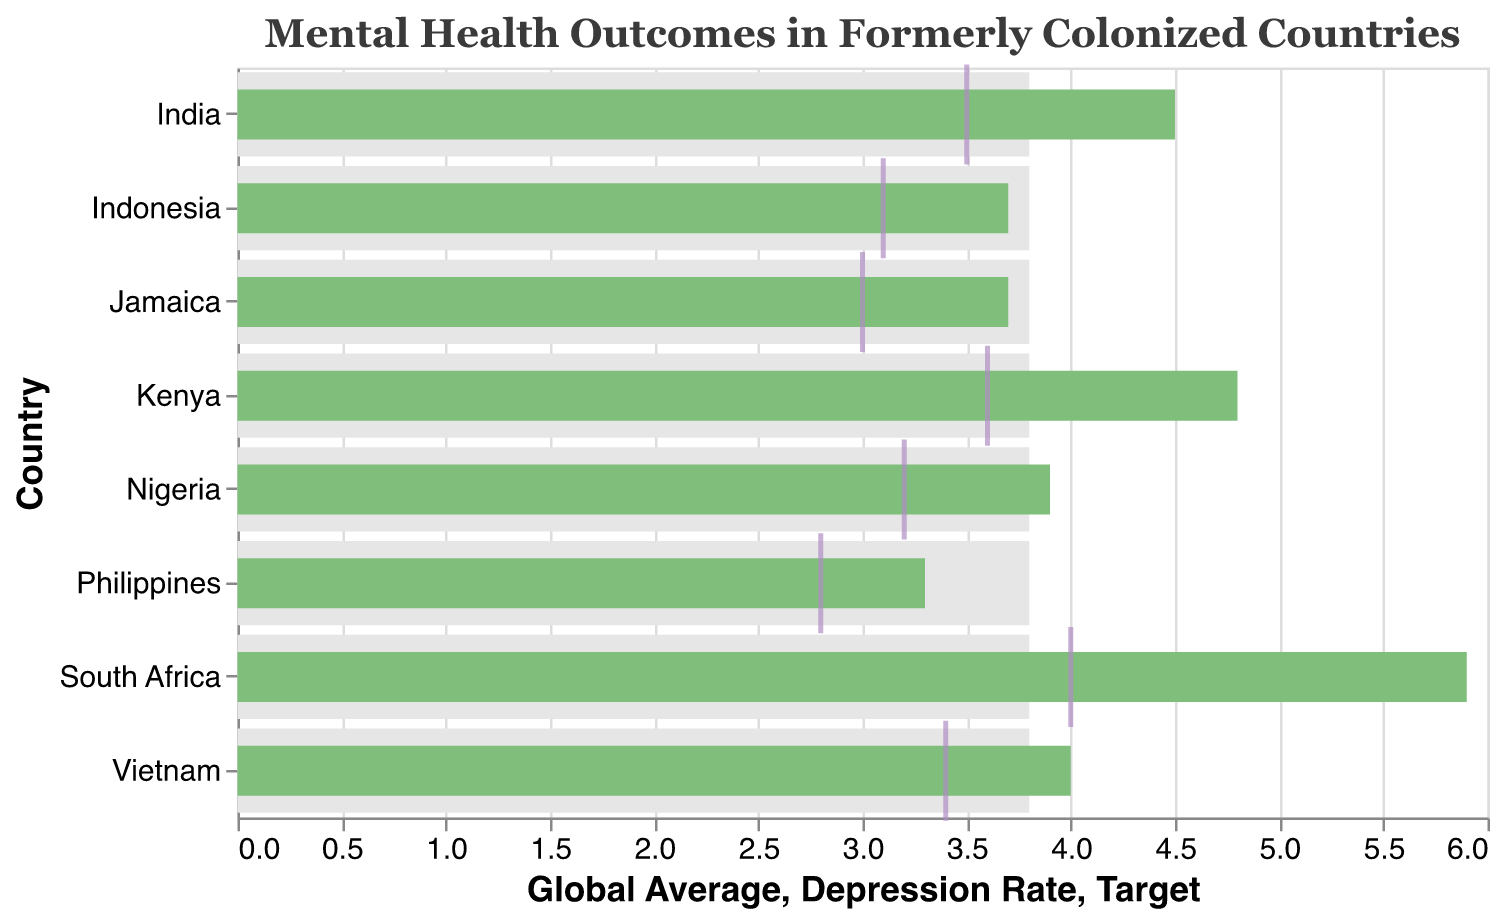What's the title of the chart? The title of the chart is given at the top and clearly states "Mental Health Outcomes in Formerly Colonized Countries".
Answer: Mental Health Outcomes in Formerly Colonized Countries What is the highest depression rate among the countries listed? By looking at the length of the green bars that represent depression rates, the entry for South Africa is the longest, indicating it has the highest rate at 5.9.
Answer: 5.9 Which country's depression rate is closest to the global average? Comparing the lengths of the green bars (depression rates) to the gray bars (global average), Nigeria and Jamaica have depression rates quite close to the global average of 3.8. Among them, Jamaica has the closest rate at 3.7.
Answer: Jamaica How does the depression rate in Kenya compare to its target? The green bar for Kenya representing its depression rate (4.8) can be compared to its tick mark for the target (3.6), showing that Kenya's rate is higher than its target.
Answer: Higher What is the difference between South Africa's depression rate and the global average? South Africa's depression rate is 5.9 and the global average is 3.8. The difference between these numbers is 5.9 - 3.8 = 2.1
Answer: 2.1 Which country has achieved its target depression rate or has a lower rate? The countries whose green bars (depression rates) are equal to or less than their tick marks (targets) are Jamaica (3.7 <= 3.0), Indonesia (3.7 <= 3.1), and the Philippines (3.3 <= 2.8).
Answer: None List the countries with a depression rate higher than the global average. Countries with green bars exceeding the gray bar, which represents the global average of 3.8, are India, Nigeria, Vietnam, Kenya, and South Africa.
Answer: India, Nigeria, Vietnam, Kenya, South Africa Arrange the countries by their depression rates in descending order. Reviewing the lengths of the green bars from longest to shortest, the order is: South Africa (5.9), Kenya (4.8), India (4.5), Vietnam (4.0), Nigeria (3.9), Jamaica (3.7), Indonesia (3.7), Philippines (3.3).
Answer: South Africa, Kenya, India, Vietnam, Nigeria, Jamaica, Indonesia, Philippines What is the average target depression rate for all listed countries? To find this, sum the target rates for all countries and divide by the number of countries: (3.5 + 3.2 + 3.4 + 3.6 + 3.0 + 3.1 + 4.0 + 2.8) / 8 = 26.6 / 8 = 3.325
Answer: 3.325 